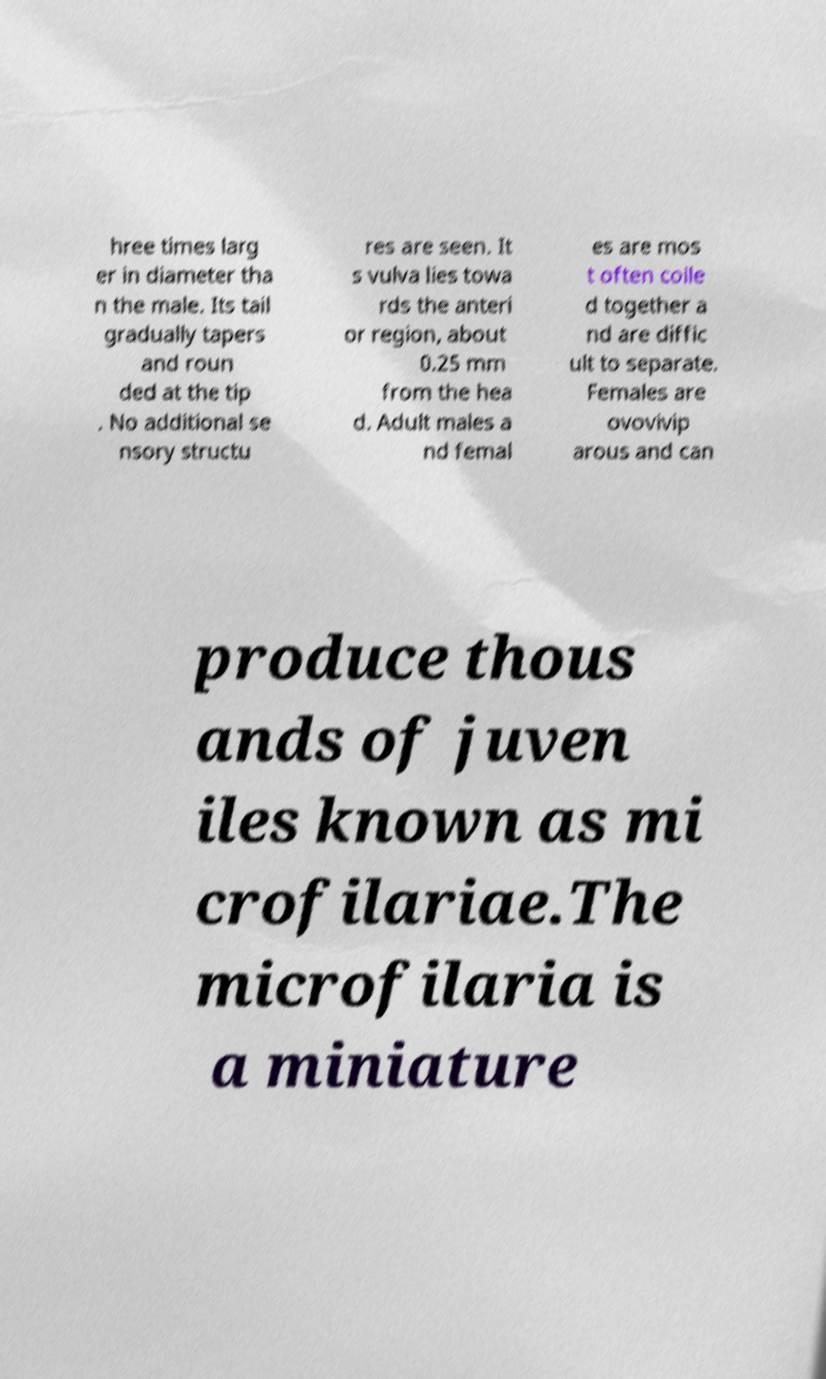I need the written content from this picture converted into text. Can you do that? hree times larg er in diameter tha n the male. Its tail gradually tapers and roun ded at the tip . No additional se nsory structu res are seen. It s vulva lies towa rds the anteri or region, about 0.25 mm from the hea d. Adult males a nd femal es are mos t often coile d together a nd are diffic ult to separate. Females are ovovivip arous and can produce thous ands of juven iles known as mi crofilariae.The microfilaria is a miniature 